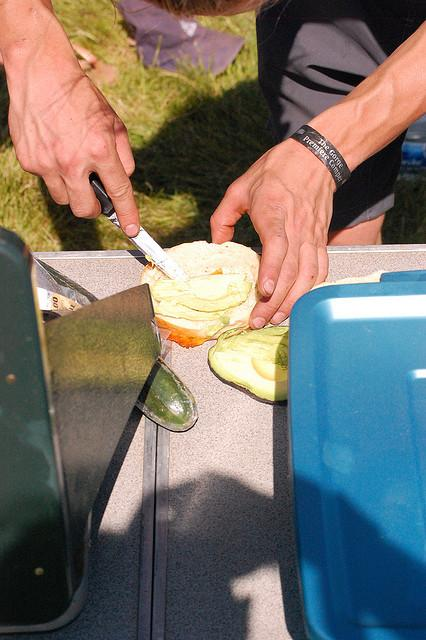At what type event is the man preparing food? Please explain your reasoning. picnic. He is outdoors as can be seen from the shadows and sunlight from above, and appears to be at a makeshift table and kitchen. 